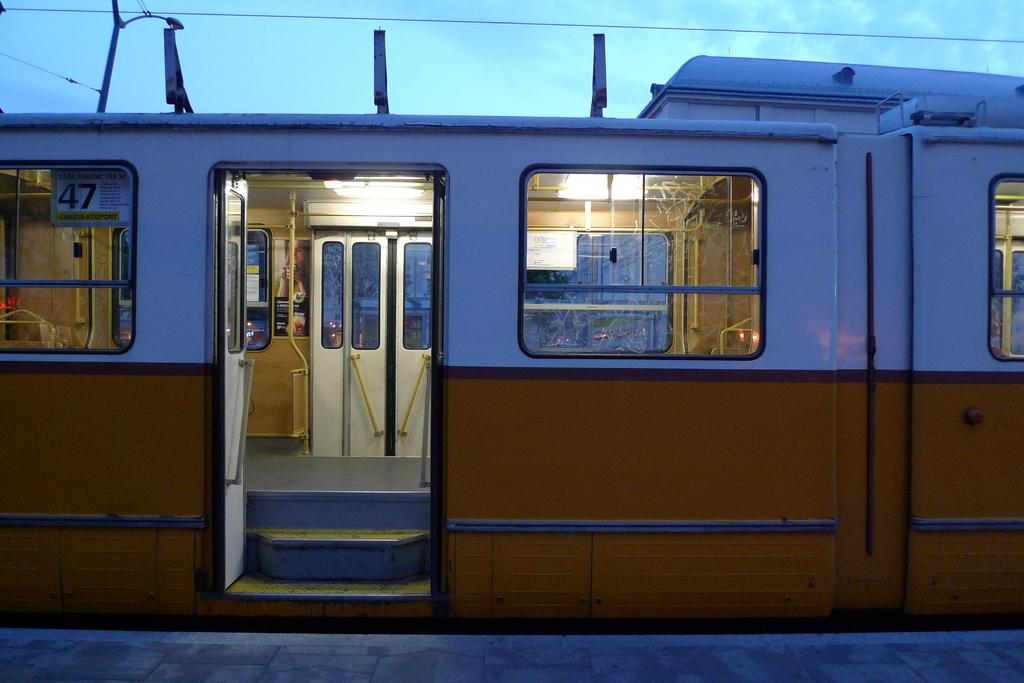What is the main subject of the image? The main subject of the image is a train. What can be seen in the background of the image? The background of the image includes a blue sky. What type of writing can be seen on the train in the image? There is no writing visible on the train in the image. What kind of shoes are the passengers wearing on the train? There are no passengers visible in the image, so it is not possible to determine what type of shoes they might be wearing. 